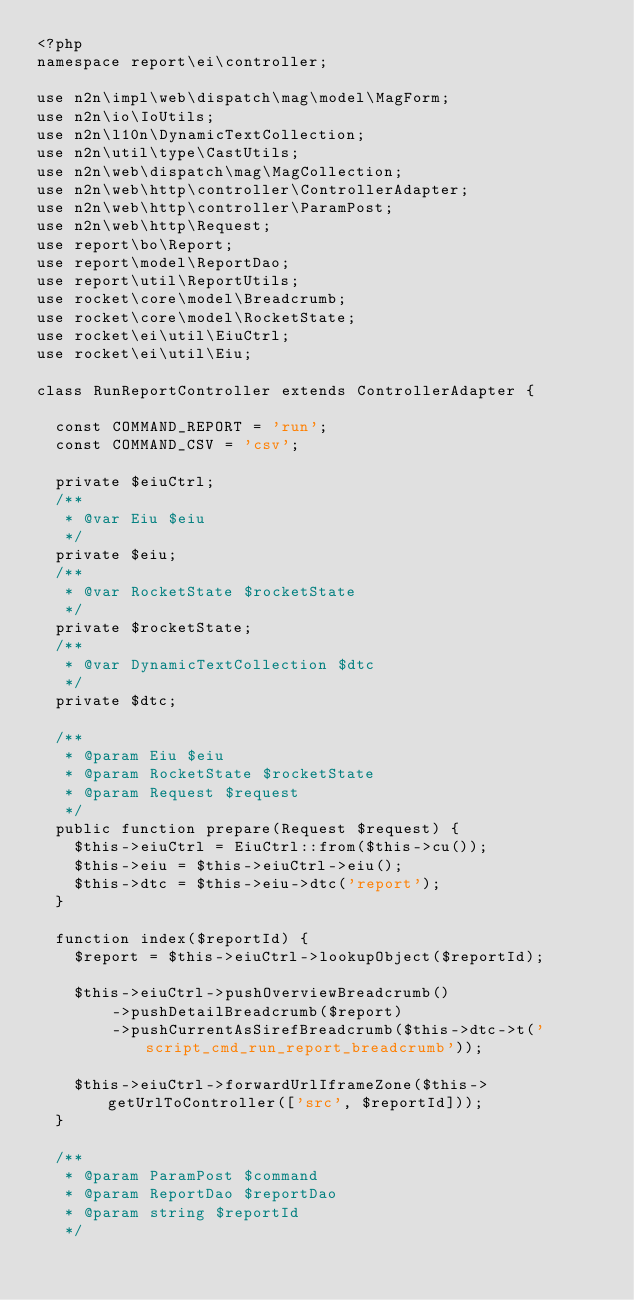Convert code to text. <code><loc_0><loc_0><loc_500><loc_500><_PHP_><?php
namespace report\ei\controller;

use n2n\impl\web\dispatch\mag\model\MagForm;
use n2n\io\IoUtils;
use n2n\l10n\DynamicTextCollection;
use n2n\util\type\CastUtils;
use n2n\web\dispatch\mag\MagCollection;
use n2n\web\http\controller\ControllerAdapter;
use n2n\web\http\controller\ParamPost;
use n2n\web\http\Request;
use report\bo\Report;
use report\model\ReportDao;
use report\util\ReportUtils;
use rocket\core\model\Breadcrumb;
use rocket\core\model\RocketState;
use rocket\ei\util\EiuCtrl;
use rocket\ei\util\Eiu;

class RunReportController extends ControllerAdapter {
	
	const COMMAND_REPORT = 'run';
	const COMMAND_CSV = 'csv';
	
	private $eiuCtrl;
	/**
	 * @var Eiu $eiu
	 */
	private $eiu;
	/**
	 * @var RocketState $rocketState
	 */
	private $rocketState;
	/**
	 * @var DynamicTextCollection $dtc
	 */
	private $dtc;
	
	/**
	 * @param Eiu $eiu
	 * @param RocketState $rocketState
	 * @param Request $request
	 */
	public function prepare(Request $request) {
		$this->eiuCtrl = EiuCtrl::from($this->cu());
		$this->eiu = $this->eiuCtrl->eiu();
		$this->dtc = $this->eiu->dtc('report');
	}
	
	function index($reportId) {
		$report = $this->eiuCtrl->lookupObject($reportId);
		
		$this->eiuCtrl->pushOverviewBreadcrumb()
				->pushDetailBreadcrumb($report)
				->pushCurrentAsSirefBreadcrumb($this->dtc->t('script_cmd_run_report_breadcrumb'));
		
		$this->eiuCtrl->forwardUrlIframeZone($this->getUrlToController(['src', $reportId]));
	}
	
	/**
	 * @param ParamPost $command
	 * @param ReportDao $reportDao
	 * @param string $reportId
	 */</code> 